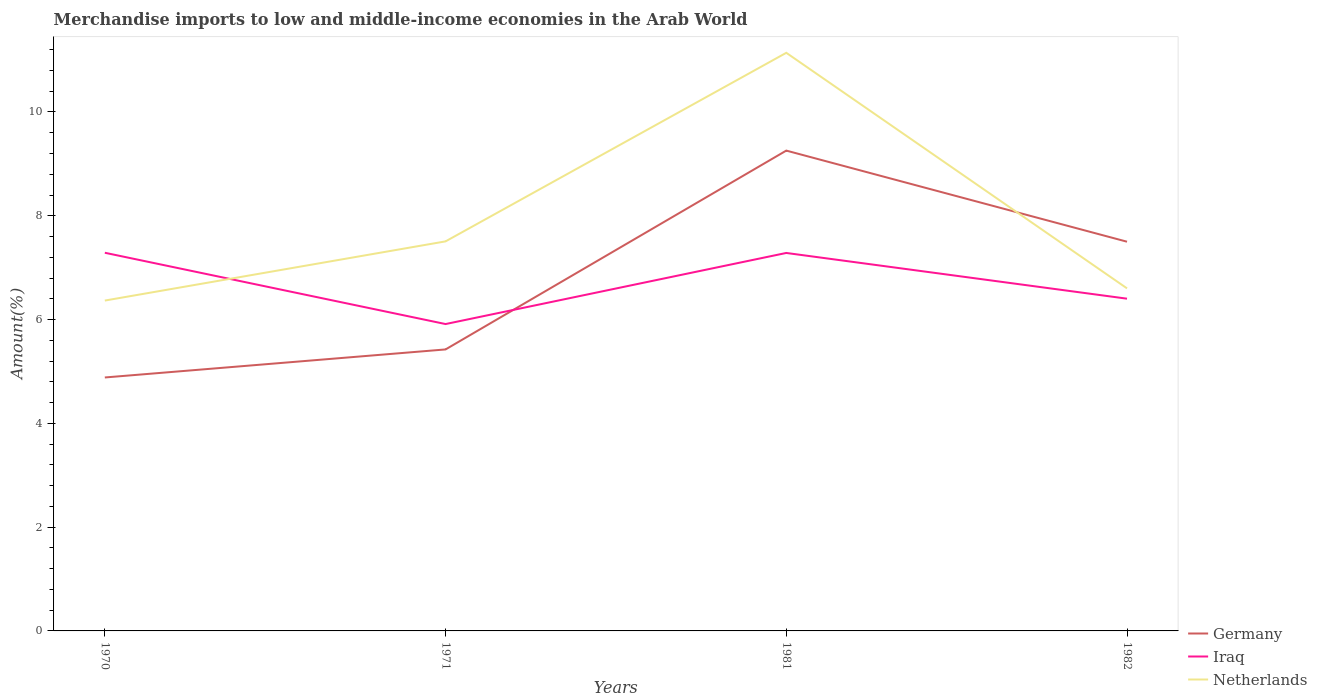Does the line corresponding to Netherlands intersect with the line corresponding to Iraq?
Make the answer very short. Yes. Across all years, what is the maximum percentage of amount earned from merchandise imports in Germany?
Your response must be concise. 4.88. What is the total percentage of amount earned from merchandise imports in Germany in the graph?
Offer a terse response. -2.08. What is the difference between the highest and the second highest percentage of amount earned from merchandise imports in Netherlands?
Make the answer very short. 4.77. How many lines are there?
Your answer should be very brief. 3. How many years are there in the graph?
Ensure brevity in your answer.  4. What is the difference between two consecutive major ticks on the Y-axis?
Ensure brevity in your answer.  2. Are the values on the major ticks of Y-axis written in scientific E-notation?
Your response must be concise. No. Does the graph contain any zero values?
Provide a short and direct response. No. Does the graph contain grids?
Keep it short and to the point. No. What is the title of the graph?
Your answer should be very brief. Merchandise imports to low and middle-income economies in the Arab World. Does "Bolivia" appear as one of the legend labels in the graph?
Your answer should be very brief. No. What is the label or title of the X-axis?
Keep it short and to the point. Years. What is the label or title of the Y-axis?
Offer a very short reply. Amount(%). What is the Amount(%) of Germany in 1970?
Give a very brief answer. 4.88. What is the Amount(%) of Iraq in 1970?
Keep it short and to the point. 7.29. What is the Amount(%) in Netherlands in 1970?
Give a very brief answer. 6.37. What is the Amount(%) in Germany in 1971?
Provide a succinct answer. 5.42. What is the Amount(%) of Iraq in 1971?
Ensure brevity in your answer.  5.91. What is the Amount(%) in Netherlands in 1971?
Ensure brevity in your answer.  7.51. What is the Amount(%) of Germany in 1981?
Provide a succinct answer. 9.26. What is the Amount(%) in Iraq in 1981?
Offer a terse response. 7.28. What is the Amount(%) of Netherlands in 1981?
Ensure brevity in your answer.  11.14. What is the Amount(%) in Germany in 1982?
Your answer should be compact. 7.5. What is the Amount(%) in Iraq in 1982?
Your answer should be compact. 6.4. What is the Amount(%) in Netherlands in 1982?
Your answer should be very brief. 6.6. Across all years, what is the maximum Amount(%) in Germany?
Provide a succinct answer. 9.26. Across all years, what is the maximum Amount(%) in Iraq?
Your answer should be very brief. 7.29. Across all years, what is the maximum Amount(%) of Netherlands?
Offer a very short reply. 11.14. Across all years, what is the minimum Amount(%) in Germany?
Keep it short and to the point. 4.88. Across all years, what is the minimum Amount(%) in Iraq?
Give a very brief answer. 5.91. Across all years, what is the minimum Amount(%) in Netherlands?
Offer a very short reply. 6.37. What is the total Amount(%) in Germany in the graph?
Give a very brief answer. 27.06. What is the total Amount(%) of Iraq in the graph?
Your answer should be compact. 26.89. What is the total Amount(%) of Netherlands in the graph?
Ensure brevity in your answer.  31.61. What is the difference between the Amount(%) in Germany in 1970 and that in 1971?
Ensure brevity in your answer.  -0.54. What is the difference between the Amount(%) of Iraq in 1970 and that in 1971?
Give a very brief answer. 1.37. What is the difference between the Amount(%) in Netherlands in 1970 and that in 1971?
Your answer should be compact. -1.14. What is the difference between the Amount(%) of Germany in 1970 and that in 1981?
Make the answer very short. -4.37. What is the difference between the Amount(%) of Iraq in 1970 and that in 1981?
Your response must be concise. 0. What is the difference between the Amount(%) of Netherlands in 1970 and that in 1981?
Keep it short and to the point. -4.77. What is the difference between the Amount(%) in Germany in 1970 and that in 1982?
Your answer should be compact. -2.62. What is the difference between the Amount(%) in Iraq in 1970 and that in 1982?
Offer a very short reply. 0.89. What is the difference between the Amount(%) in Netherlands in 1970 and that in 1982?
Your answer should be compact. -0.24. What is the difference between the Amount(%) in Germany in 1971 and that in 1981?
Your response must be concise. -3.83. What is the difference between the Amount(%) in Iraq in 1971 and that in 1981?
Make the answer very short. -1.37. What is the difference between the Amount(%) in Netherlands in 1971 and that in 1981?
Provide a succinct answer. -3.63. What is the difference between the Amount(%) in Germany in 1971 and that in 1982?
Provide a succinct answer. -2.08. What is the difference between the Amount(%) of Iraq in 1971 and that in 1982?
Offer a very short reply. -0.49. What is the difference between the Amount(%) in Netherlands in 1971 and that in 1982?
Your answer should be compact. 0.91. What is the difference between the Amount(%) of Germany in 1981 and that in 1982?
Provide a succinct answer. 1.76. What is the difference between the Amount(%) in Iraq in 1981 and that in 1982?
Ensure brevity in your answer.  0.88. What is the difference between the Amount(%) of Netherlands in 1981 and that in 1982?
Offer a very short reply. 4.54. What is the difference between the Amount(%) in Germany in 1970 and the Amount(%) in Iraq in 1971?
Ensure brevity in your answer.  -1.03. What is the difference between the Amount(%) of Germany in 1970 and the Amount(%) of Netherlands in 1971?
Keep it short and to the point. -2.62. What is the difference between the Amount(%) of Iraq in 1970 and the Amount(%) of Netherlands in 1971?
Your answer should be very brief. -0.22. What is the difference between the Amount(%) in Germany in 1970 and the Amount(%) in Iraq in 1981?
Offer a very short reply. -2.4. What is the difference between the Amount(%) in Germany in 1970 and the Amount(%) in Netherlands in 1981?
Offer a terse response. -6.26. What is the difference between the Amount(%) in Iraq in 1970 and the Amount(%) in Netherlands in 1981?
Ensure brevity in your answer.  -3.85. What is the difference between the Amount(%) in Germany in 1970 and the Amount(%) in Iraq in 1982?
Your answer should be very brief. -1.52. What is the difference between the Amount(%) in Germany in 1970 and the Amount(%) in Netherlands in 1982?
Your answer should be very brief. -1.72. What is the difference between the Amount(%) in Iraq in 1970 and the Amount(%) in Netherlands in 1982?
Provide a short and direct response. 0.69. What is the difference between the Amount(%) of Germany in 1971 and the Amount(%) of Iraq in 1981?
Your response must be concise. -1.86. What is the difference between the Amount(%) in Germany in 1971 and the Amount(%) in Netherlands in 1981?
Provide a succinct answer. -5.72. What is the difference between the Amount(%) of Iraq in 1971 and the Amount(%) of Netherlands in 1981?
Ensure brevity in your answer.  -5.23. What is the difference between the Amount(%) in Germany in 1971 and the Amount(%) in Iraq in 1982?
Offer a very short reply. -0.98. What is the difference between the Amount(%) in Germany in 1971 and the Amount(%) in Netherlands in 1982?
Provide a succinct answer. -1.18. What is the difference between the Amount(%) of Iraq in 1971 and the Amount(%) of Netherlands in 1982?
Provide a short and direct response. -0.69. What is the difference between the Amount(%) of Germany in 1981 and the Amount(%) of Iraq in 1982?
Offer a terse response. 2.85. What is the difference between the Amount(%) in Germany in 1981 and the Amount(%) in Netherlands in 1982?
Offer a very short reply. 2.65. What is the difference between the Amount(%) of Iraq in 1981 and the Amount(%) of Netherlands in 1982?
Make the answer very short. 0.68. What is the average Amount(%) in Germany per year?
Provide a short and direct response. 6.77. What is the average Amount(%) of Iraq per year?
Your response must be concise. 6.72. What is the average Amount(%) in Netherlands per year?
Keep it short and to the point. 7.9. In the year 1970, what is the difference between the Amount(%) of Germany and Amount(%) of Iraq?
Offer a very short reply. -2.4. In the year 1970, what is the difference between the Amount(%) of Germany and Amount(%) of Netherlands?
Keep it short and to the point. -1.48. In the year 1970, what is the difference between the Amount(%) in Iraq and Amount(%) in Netherlands?
Offer a very short reply. 0.92. In the year 1971, what is the difference between the Amount(%) of Germany and Amount(%) of Iraq?
Give a very brief answer. -0.49. In the year 1971, what is the difference between the Amount(%) of Germany and Amount(%) of Netherlands?
Provide a short and direct response. -2.08. In the year 1971, what is the difference between the Amount(%) in Iraq and Amount(%) in Netherlands?
Your answer should be compact. -1.59. In the year 1981, what is the difference between the Amount(%) in Germany and Amount(%) in Iraq?
Make the answer very short. 1.97. In the year 1981, what is the difference between the Amount(%) in Germany and Amount(%) in Netherlands?
Give a very brief answer. -1.88. In the year 1981, what is the difference between the Amount(%) in Iraq and Amount(%) in Netherlands?
Keep it short and to the point. -3.86. In the year 1982, what is the difference between the Amount(%) of Germany and Amount(%) of Iraq?
Provide a succinct answer. 1.1. In the year 1982, what is the difference between the Amount(%) of Germany and Amount(%) of Netherlands?
Provide a short and direct response. 0.9. In the year 1982, what is the difference between the Amount(%) of Iraq and Amount(%) of Netherlands?
Provide a succinct answer. -0.2. What is the ratio of the Amount(%) in Germany in 1970 to that in 1971?
Your answer should be compact. 0.9. What is the ratio of the Amount(%) in Iraq in 1970 to that in 1971?
Your response must be concise. 1.23. What is the ratio of the Amount(%) of Netherlands in 1970 to that in 1971?
Provide a short and direct response. 0.85. What is the ratio of the Amount(%) in Germany in 1970 to that in 1981?
Your answer should be compact. 0.53. What is the ratio of the Amount(%) in Germany in 1970 to that in 1982?
Offer a very short reply. 0.65. What is the ratio of the Amount(%) of Iraq in 1970 to that in 1982?
Offer a very short reply. 1.14. What is the ratio of the Amount(%) in Netherlands in 1970 to that in 1982?
Offer a very short reply. 0.96. What is the ratio of the Amount(%) of Germany in 1971 to that in 1981?
Your answer should be compact. 0.59. What is the ratio of the Amount(%) of Iraq in 1971 to that in 1981?
Offer a terse response. 0.81. What is the ratio of the Amount(%) in Netherlands in 1971 to that in 1981?
Your answer should be compact. 0.67. What is the ratio of the Amount(%) in Germany in 1971 to that in 1982?
Ensure brevity in your answer.  0.72. What is the ratio of the Amount(%) in Iraq in 1971 to that in 1982?
Offer a very short reply. 0.92. What is the ratio of the Amount(%) in Netherlands in 1971 to that in 1982?
Ensure brevity in your answer.  1.14. What is the ratio of the Amount(%) in Germany in 1981 to that in 1982?
Give a very brief answer. 1.23. What is the ratio of the Amount(%) of Iraq in 1981 to that in 1982?
Your answer should be very brief. 1.14. What is the ratio of the Amount(%) of Netherlands in 1981 to that in 1982?
Offer a terse response. 1.69. What is the difference between the highest and the second highest Amount(%) of Germany?
Ensure brevity in your answer.  1.76. What is the difference between the highest and the second highest Amount(%) of Iraq?
Your answer should be compact. 0. What is the difference between the highest and the second highest Amount(%) of Netherlands?
Your answer should be compact. 3.63. What is the difference between the highest and the lowest Amount(%) in Germany?
Keep it short and to the point. 4.37. What is the difference between the highest and the lowest Amount(%) of Iraq?
Your answer should be very brief. 1.37. What is the difference between the highest and the lowest Amount(%) in Netherlands?
Provide a short and direct response. 4.77. 